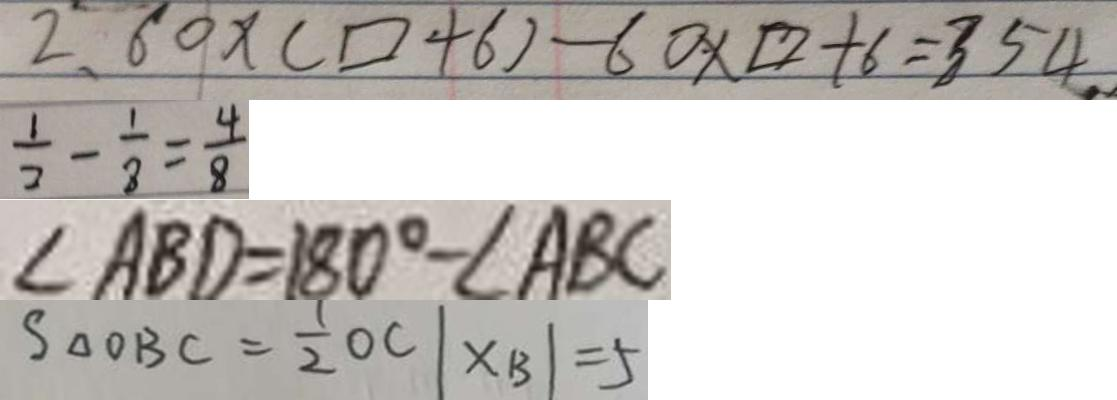Convert formula to latex. <formula><loc_0><loc_0><loc_500><loc_500>2 . 6 0 \times ( \square + 6 ) - 6 0 \times \square + 6 = 3 5 4 . 
 \frac { 1 } { 2 } - \frac { 1 } { 8 } = \frac { 4 } { 8 } 
 \angle A B D = 1 8 0 ^ { \circ } - \angle A B C 
 S _ { \Delta } O B C = \frac { 1 } { 2 } O C \vert x _ { B } \vert = 5</formula> 